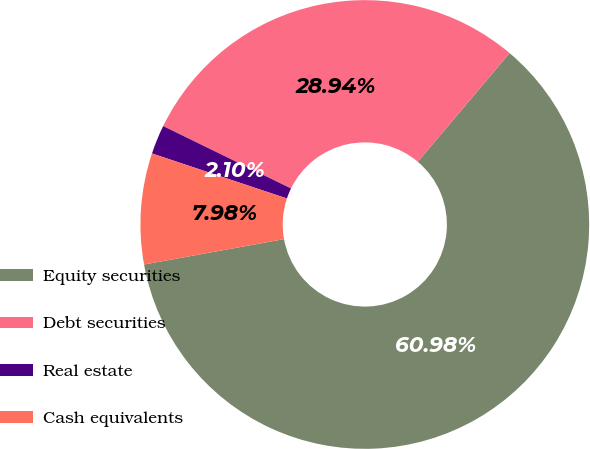Convert chart. <chart><loc_0><loc_0><loc_500><loc_500><pie_chart><fcel>Equity securities<fcel>Debt securities<fcel>Real estate<fcel>Cash equivalents<nl><fcel>60.98%<fcel>28.94%<fcel>2.1%<fcel>7.98%<nl></chart> 